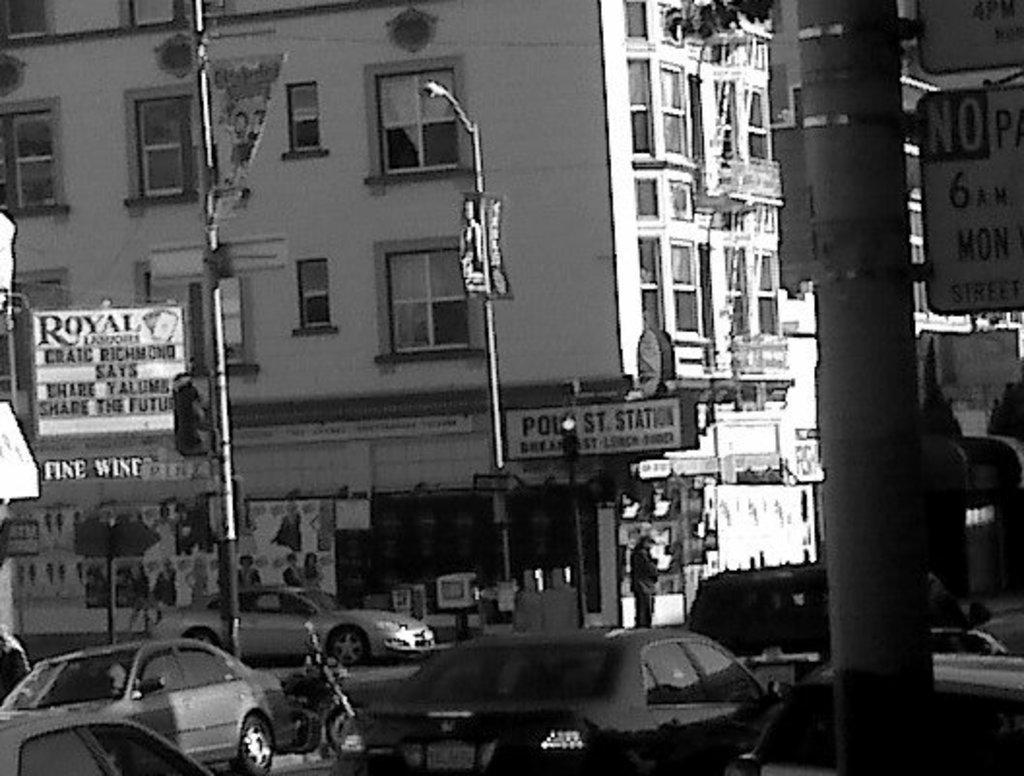How would you summarize this image in a sentence or two? This image is in black and white where we can see vehicles moving on the road, boards to the pole, light poles, traffic signal poles and buildings in the background. 